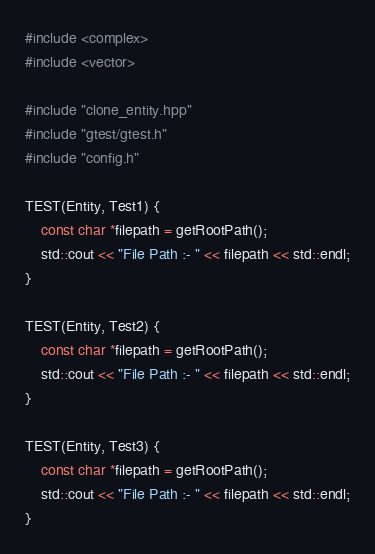Convert code to text. <code><loc_0><loc_0><loc_500><loc_500><_C++_>#include <complex>
#include <vector>

#include "clone_entity.hpp"
#include "gtest/gtest.h"
#include "config.h"

TEST(Entity, Test1) {
    const char *filepath = getRootPath();
    std::cout << "File Path :- " << filepath << std::endl;
}

TEST(Entity, Test2) {
    const char *filepath = getRootPath();
    std::cout << "File Path :- " << filepath << std::endl;
}

TEST(Entity, Test3) {
    const char *filepath = getRootPath();
    std::cout << "File Path :- " << filepath << std::endl;
}
</code> 